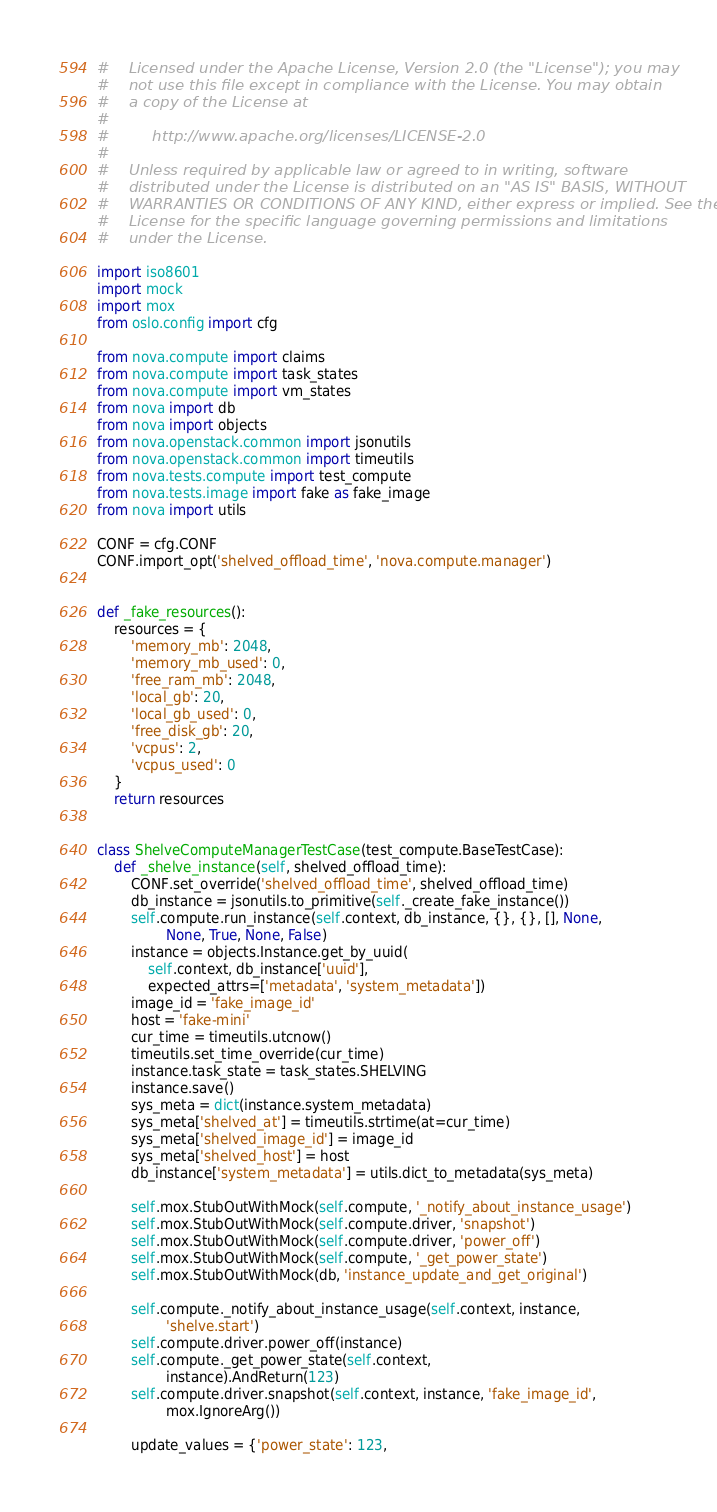Convert code to text. <code><loc_0><loc_0><loc_500><loc_500><_Python_>#    Licensed under the Apache License, Version 2.0 (the "License"); you may
#    not use this file except in compliance with the License. You may obtain
#    a copy of the License at
#
#         http://www.apache.org/licenses/LICENSE-2.0
#
#    Unless required by applicable law or agreed to in writing, software
#    distributed under the License is distributed on an "AS IS" BASIS, WITHOUT
#    WARRANTIES OR CONDITIONS OF ANY KIND, either express or implied. See the
#    License for the specific language governing permissions and limitations
#    under the License.

import iso8601
import mock
import mox
from oslo.config import cfg

from nova.compute import claims
from nova.compute import task_states
from nova.compute import vm_states
from nova import db
from nova import objects
from nova.openstack.common import jsonutils
from nova.openstack.common import timeutils
from nova.tests.compute import test_compute
from nova.tests.image import fake as fake_image
from nova import utils

CONF = cfg.CONF
CONF.import_opt('shelved_offload_time', 'nova.compute.manager')


def _fake_resources():
    resources = {
        'memory_mb': 2048,
        'memory_mb_used': 0,
        'free_ram_mb': 2048,
        'local_gb': 20,
        'local_gb_used': 0,
        'free_disk_gb': 20,
        'vcpus': 2,
        'vcpus_used': 0
    }
    return resources


class ShelveComputeManagerTestCase(test_compute.BaseTestCase):
    def _shelve_instance(self, shelved_offload_time):
        CONF.set_override('shelved_offload_time', shelved_offload_time)
        db_instance = jsonutils.to_primitive(self._create_fake_instance())
        self.compute.run_instance(self.context, db_instance, {}, {}, [], None,
                None, True, None, False)
        instance = objects.Instance.get_by_uuid(
            self.context, db_instance['uuid'],
            expected_attrs=['metadata', 'system_metadata'])
        image_id = 'fake_image_id'
        host = 'fake-mini'
        cur_time = timeutils.utcnow()
        timeutils.set_time_override(cur_time)
        instance.task_state = task_states.SHELVING
        instance.save()
        sys_meta = dict(instance.system_metadata)
        sys_meta['shelved_at'] = timeutils.strtime(at=cur_time)
        sys_meta['shelved_image_id'] = image_id
        sys_meta['shelved_host'] = host
        db_instance['system_metadata'] = utils.dict_to_metadata(sys_meta)

        self.mox.StubOutWithMock(self.compute, '_notify_about_instance_usage')
        self.mox.StubOutWithMock(self.compute.driver, 'snapshot')
        self.mox.StubOutWithMock(self.compute.driver, 'power_off')
        self.mox.StubOutWithMock(self.compute, '_get_power_state')
        self.mox.StubOutWithMock(db, 'instance_update_and_get_original')

        self.compute._notify_about_instance_usage(self.context, instance,
                'shelve.start')
        self.compute.driver.power_off(instance)
        self.compute._get_power_state(self.context,
                instance).AndReturn(123)
        self.compute.driver.snapshot(self.context, instance, 'fake_image_id',
                mox.IgnoreArg())

        update_values = {'power_state': 123,</code> 